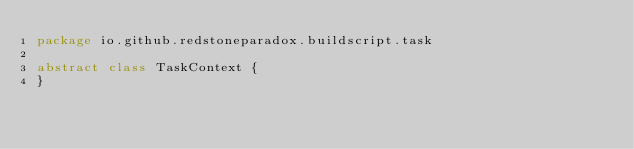Convert code to text. <code><loc_0><loc_0><loc_500><loc_500><_Kotlin_>package io.github.redstoneparadox.buildscript.task

abstract class TaskContext {
}</code> 